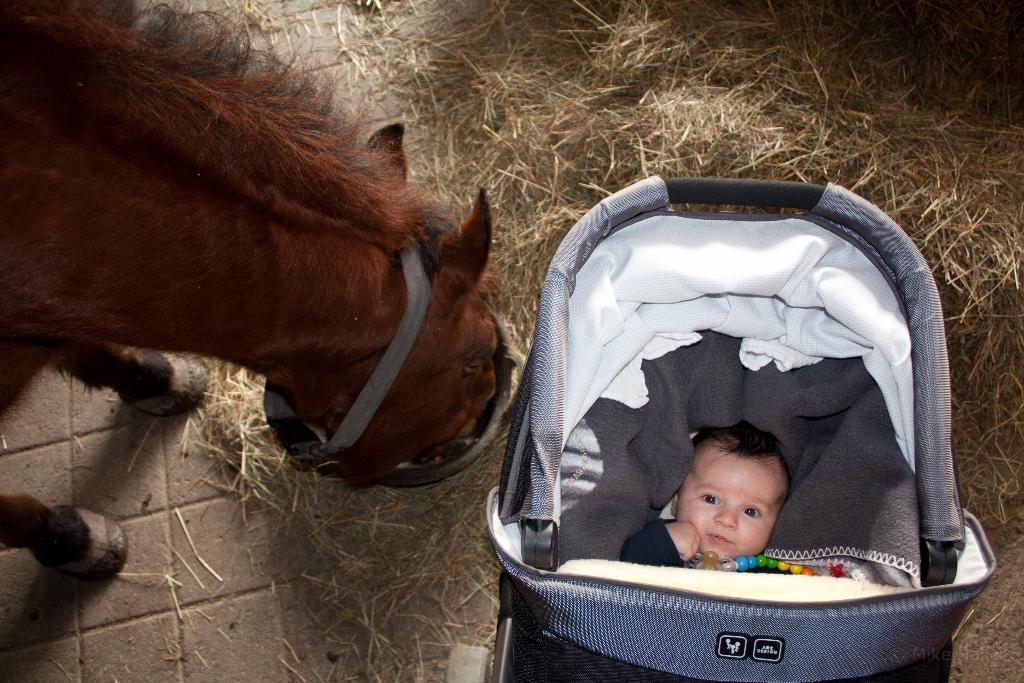Describe this image in one or two sentences. In this image we can see a baby in the stroller and on the left side of the image we can see a horse. There is a straw stack on the ground. 